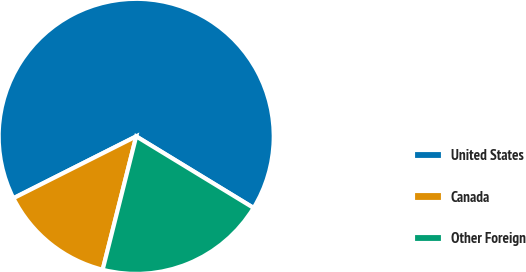<chart> <loc_0><loc_0><loc_500><loc_500><pie_chart><fcel>United States<fcel>Canada<fcel>Other Foreign<nl><fcel>66.14%<fcel>13.65%<fcel>20.21%<nl></chart> 